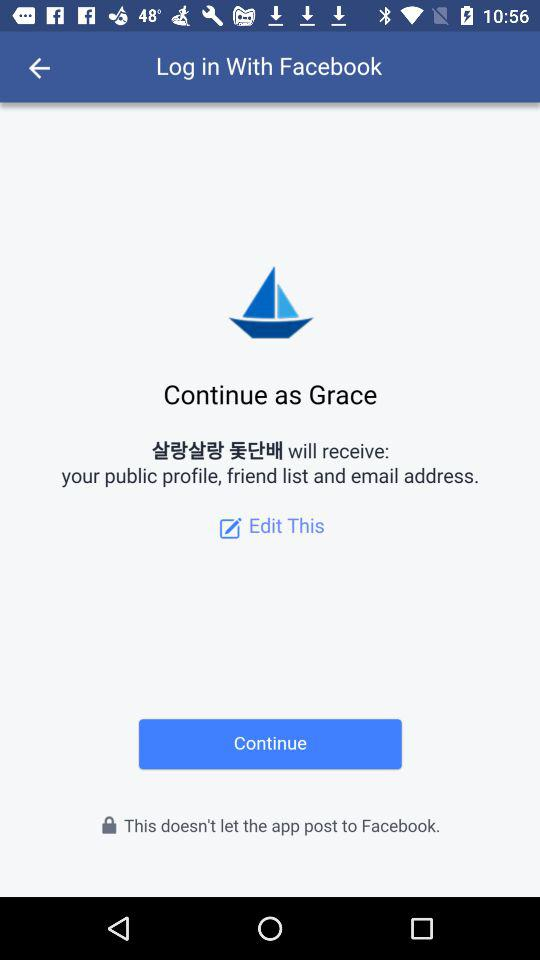What is the user name to continue to the login page? The user name is Grace. 